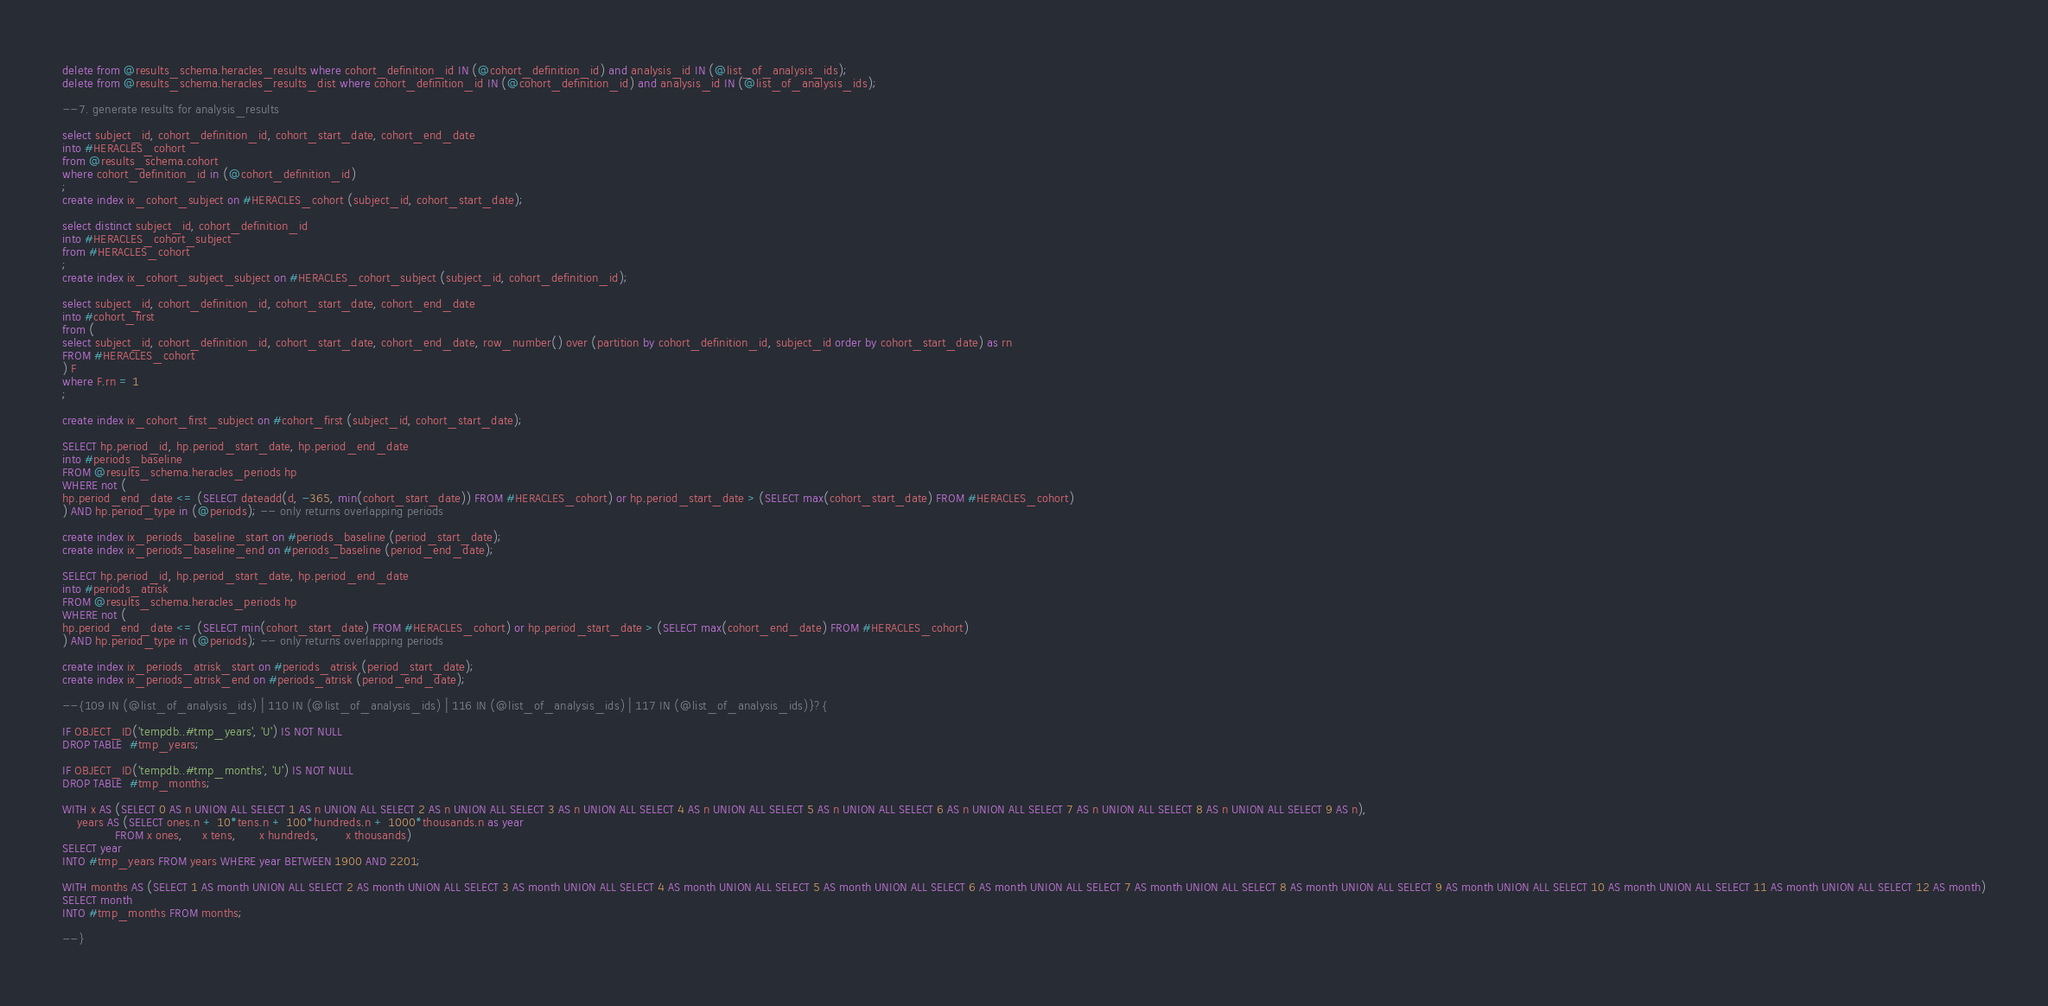Convert code to text. <code><loc_0><loc_0><loc_500><loc_500><_SQL_>delete from @results_schema.heracles_results where cohort_definition_id IN (@cohort_definition_id) and analysis_id IN (@list_of_analysis_ids);
delete from @results_schema.heracles_results_dist where cohort_definition_id IN (@cohort_definition_id) and analysis_id IN (@list_of_analysis_ids);

--7. generate results for analysis_results

select subject_id, cohort_definition_id, cohort_start_date, cohort_end_date
into #HERACLES_cohort
from @results_schema.cohort
where cohort_definition_id in (@cohort_definition_id)
;
create index ix_cohort_subject on #HERACLES_cohort (subject_id, cohort_start_date);

select distinct subject_id, cohort_definition_id
into #HERACLES_cohort_subject
from #HERACLES_cohort
;
create index ix_cohort_subject_subject on #HERACLES_cohort_subject (subject_id, cohort_definition_id);

select subject_id, cohort_definition_id, cohort_start_date, cohort_end_date
into #cohort_first
from (
select subject_id, cohort_definition_id, cohort_start_date, cohort_end_date, row_number() over (partition by cohort_definition_id, subject_id order by cohort_start_date) as rn
FROM #HERACLES_cohort
) F
where F.rn = 1
;

create index ix_cohort_first_subject on #cohort_first (subject_id, cohort_start_date);

SELECT hp.period_id, hp.period_start_date, hp.period_end_date
into #periods_baseline
FROM @results_schema.heracles_periods hp
WHERE not (
hp.period_end_date <= (SELECT dateadd(d, -365, min(cohort_start_date)) FROM #HERACLES_cohort) or hp.period_start_date > (SELECT max(cohort_start_date) FROM #HERACLES_cohort)
) AND hp.period_type in (@periods); -- only returns overlapping periods

create index ix_periods_baseline_start on #periods_baseline (period_start_date);
create index ix_periods_baseline_end on #periods_baseline (period_end_date);

SELECT hp.period_id, hp.period_start_date, hp.period_end_date
into #periods_atrisk
FROM @results_schema.heracles_periods hp
WHERE not (
hp.period_end_date <= (SELECT min(cohort_start_date) FROM #HERACLES_cohort) or hp.period_start_date > (SELECT max(cohort_end_date) FROM #HERACLES_cohort)
) AND hp.period_type in (@periods); -- only returns overlapping periods

create index ix_periods_atrisk_start on #periods_atrisk (period_start_date);
create index ix_periods_atrisk_end on #periods_atrisk (period_end_date);

--{109 IN (@list_of_analysis_ids) | 110 IN (@list_of_analysis_ids) | 116 IN (@list_of_analysis_ids) | 117 IN (@list_of_analysis_ids)}?{

IF OBJECT_ID('tempdb..#tmp_years', 'U') IS NOT NULL
DROP TABLE  #tmp_years;

IF OBJECT_ID('tempdb..#tmp_months', 'U') IS NOT NULL
DROP TABLE  #tmp_months;

WITH x AS (SELECT 0 AS n UNION ALL SELECT 1 AS n UNION ALL SELECT 2 AS n UNION ALL SELECT 3 AS n UNION ALL SELECT 4 AS n UNION ALL SELECT 5 AS n UNION ALL SELECT 6 AS n UNION ALL SELECT 7 AS n UNION ALL SELECT 8 AS n UNION ALL SELECT 9 AS n),
    years AS (SELECT ones.n + 10*tens.n + 100*hundreds.n + 1000*thousands.n as year
              FROM x ones,     x tens,      x hundreds,       x thousands)
SELECT year
INTO #tmp_years FROM years WHERE year BETWEEN 1900 AND 2201;

WITH months AS (SELECT 1 AS month UNION ALL SELECT 2 AS month UNION ALL SELECT 3 AS month UNION ALL SELECT 4 AS month UNION ALL SELECT 5 AS month UNION ALL SELECT 6 AS month UNION ALL SELECT 7 AS month UNION ALL SELECT 8 AS month UNION ALL SELECT 9 AS month UNION ALL SELECT 10 AS month UNION ALL SELECT 11 AS month UNION ALL SELECT 12 AS month)
SELECT month
INTO #tmp_months FROM months;

--}</code> 